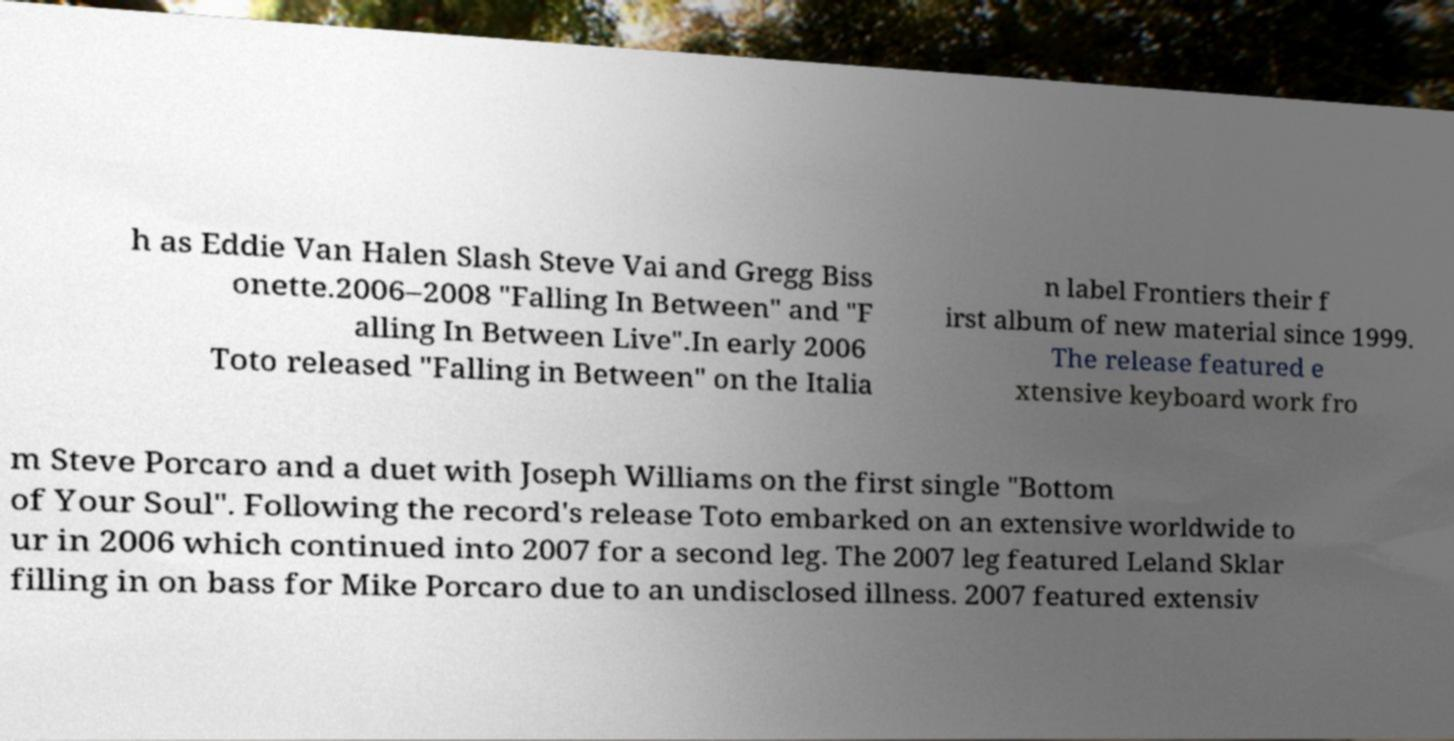Can you accurately transcribe the text from the provided image for me? h as Eddie Van Halen Slash Steve Vai and Gregg Biss onette.2006–2008 "Falling In Between" and "F alling In Between Live".In early 2006 Toto released "Falling in Between" on the Italia n label Frontiers their f irst album of new material since 1999. The release featured e xtensive keyboard work fro m Steve Porcaro and a duet with Joseph Williams on the first single "Bottom of Your Soul". Following the record's release Toto embarked on an extensive worldwide to ur in 2006 which continued into 2007 for a second leg. The 2007 leg featured Leland Sklar filling in on bass for Mike Porcaro due to an undisclosed illness. 2007 featured extensiv 